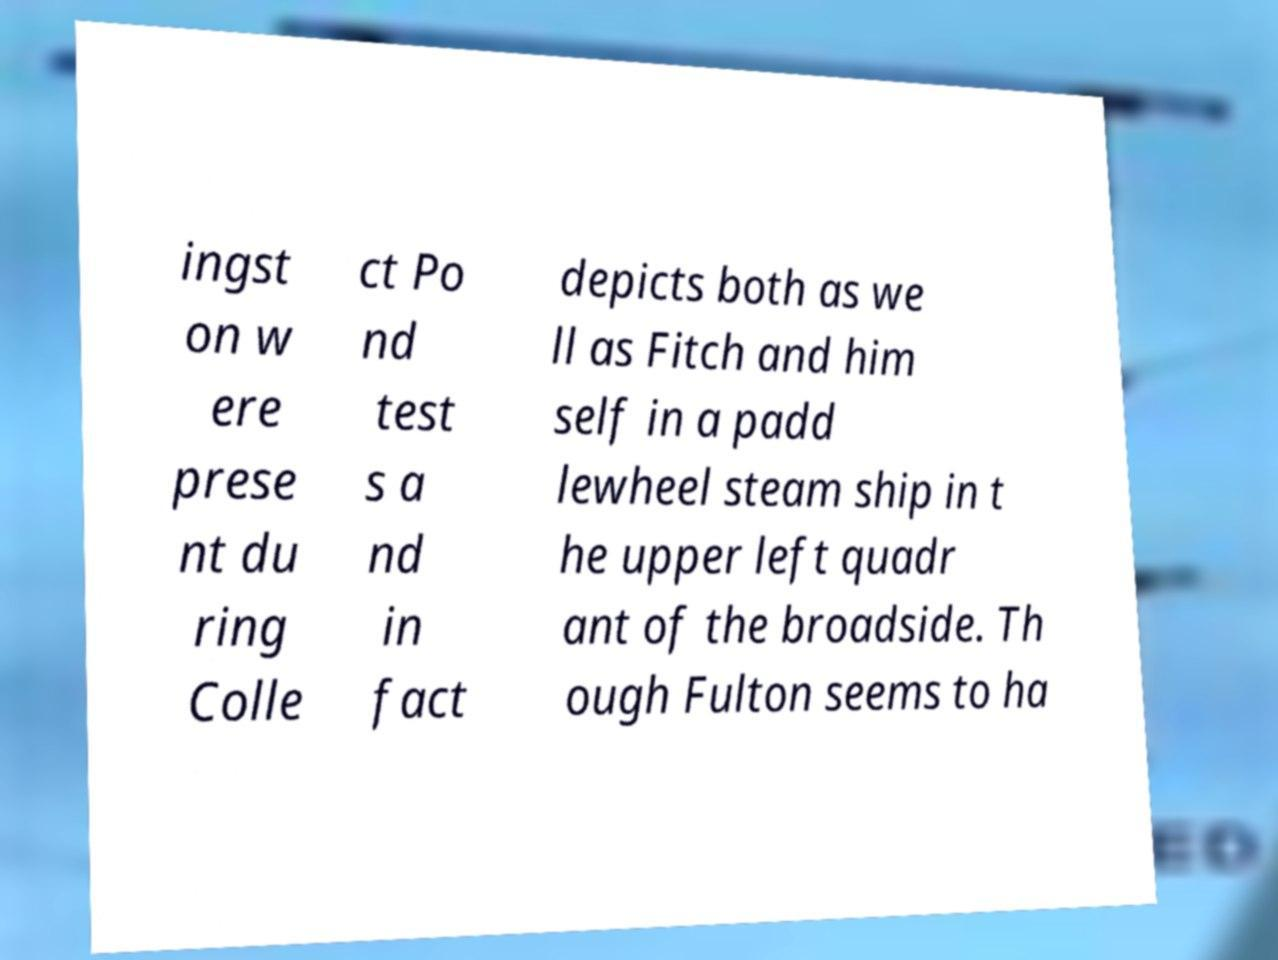Can you accurately transcribe the text from the provided image for me? ingst on w ere prese nt du ring Colle ct Po nd test s a nd in fact depicts both as we ll as Fitch and him self in a padd lewheel steam ship in t he upper left quadr ant of the broadside. Th ough Fulton seems to ha 